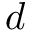<formula> <loc_0><loc_0><loc_500><loc_500>d</formula> 